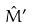<formula> <loc_0><loc_0><loc_500><loc_500>\hat { M } ^ { \prime }</formula> 